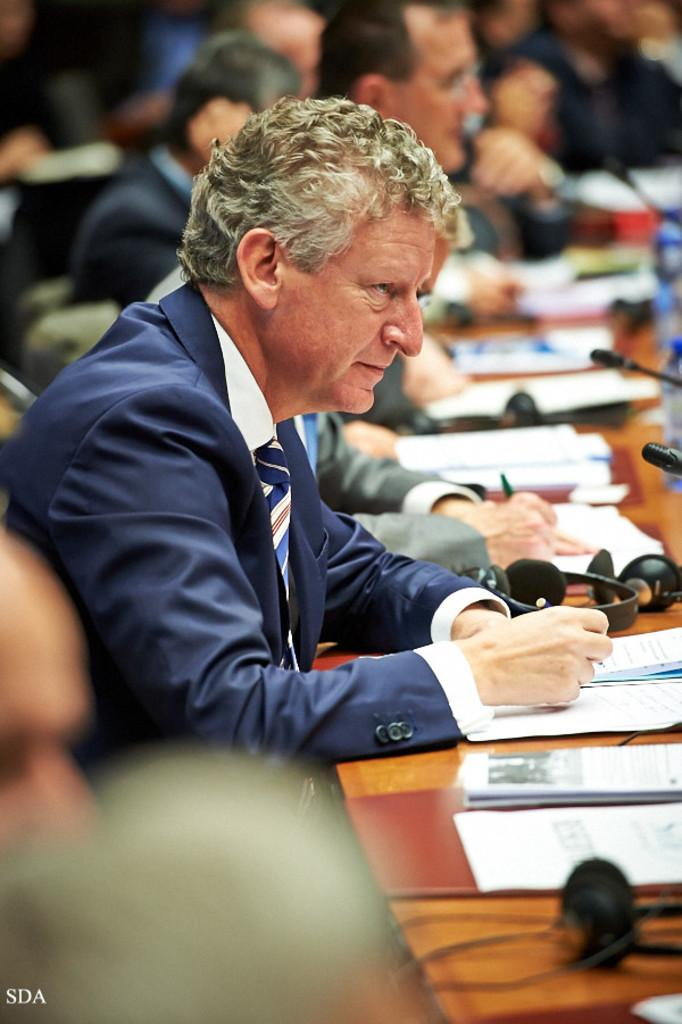Who or what can be seen in the image? There are people in the image. What object is present in the image that might be used for eating or working? There is a table in the image. What items are on the table in the image? Papers, headphones, microphones, and bottles are present on the table. What type of cable can be seen connecting the hall to the control room in the image? There is no cable, hall, or control room present in the image. 